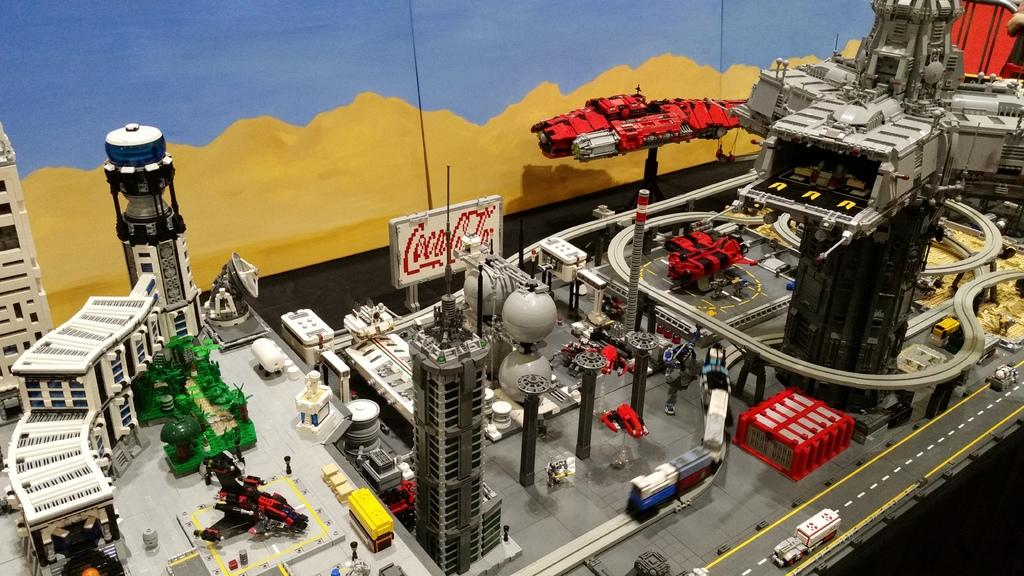What type of structures can be seen in the image? There are buildings and towers in the image. What is visible on the roads in the image? There are fleets of vehicles on the road in the image. What are the light poles used for in the image? The light poles are used for illumination in the image. What can be seen in the sky in the image? The sky is visible in the image. How does the image appear to be created? The image appears to be a painting or a photo. What type of advice can be seen written on the pocket in the image? There is no pocket or advice present in the image. What type of knife is being used by the person in the image? There is no person or knife present in the image. 